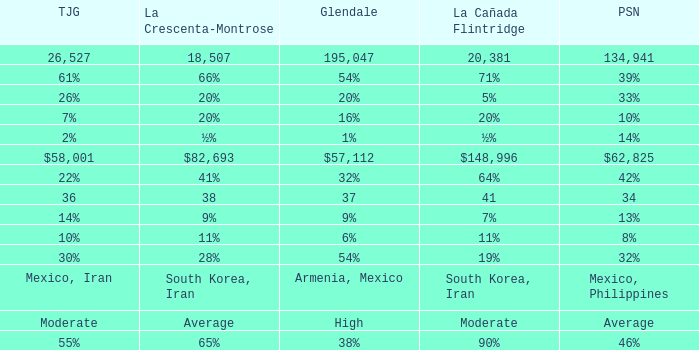What is the figure for Tujunga when Pasadena is 134,941? 26527.0. 